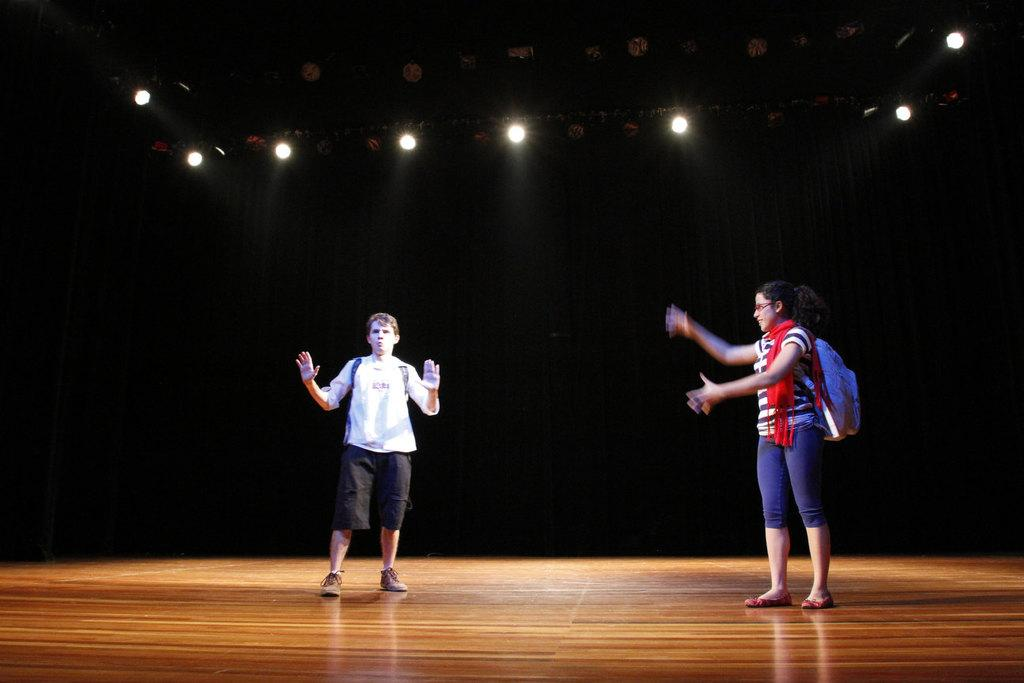How many people are on the stage in the image? There are two people standing on the stage in the image. What are the people wearing? The people are wearing bags. What can be seen at the top of the image? There are lights visible at the top of the image. How would you describe the background of the image? The background of the image appears to be dark. What type of tub is visible in the image? There is no tub present in the image. What industry is represented by the people wearing bags in the image? The image does not provide enough information to determine the industry represented by the people wearing bags. 